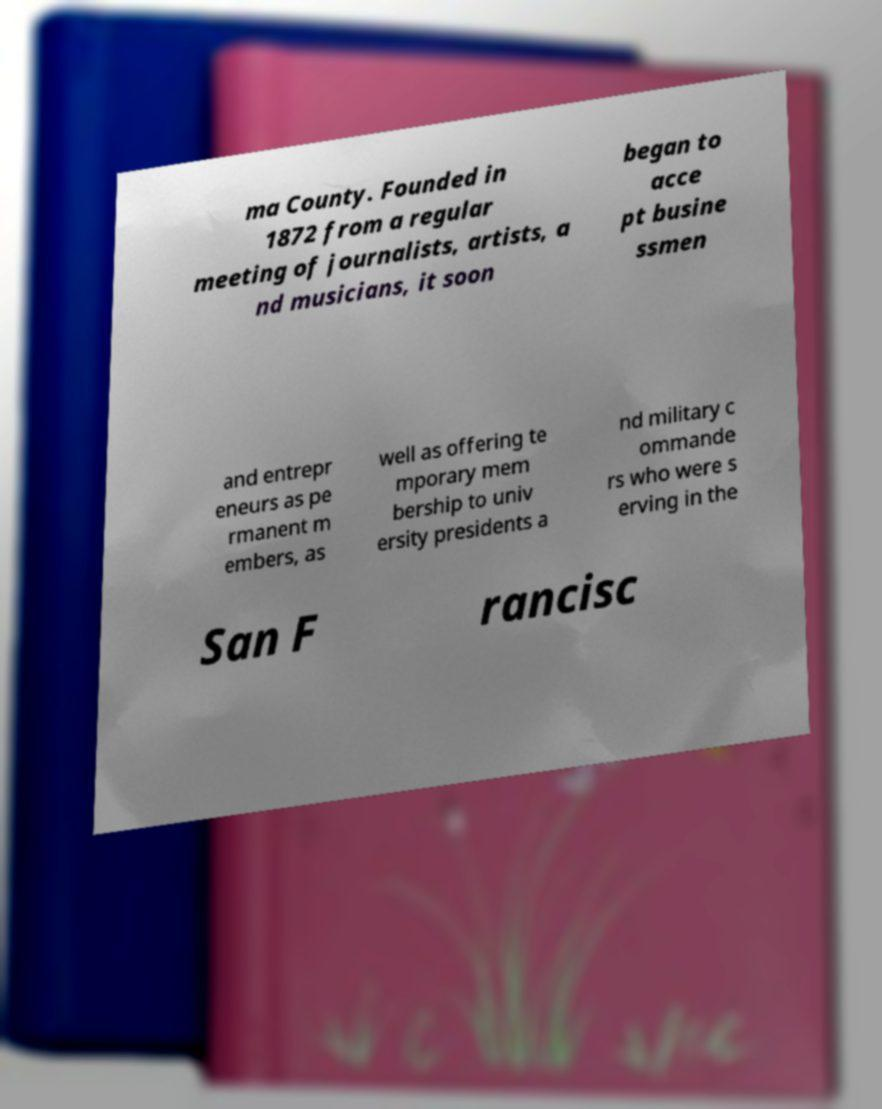What messages or text are displayed in this image? I need them in a readable, typed format. ma County. Founded in 1872 from a regular meeting of journalists, artists, a nd musicians, it soon began to acce pt busine ssmen and entrepr eneurs as pe rmanent m embers, as well as offering te mporary mem bership to univ ersity presidents a nd military c ommande rs who were s erving in the San F rancisc 